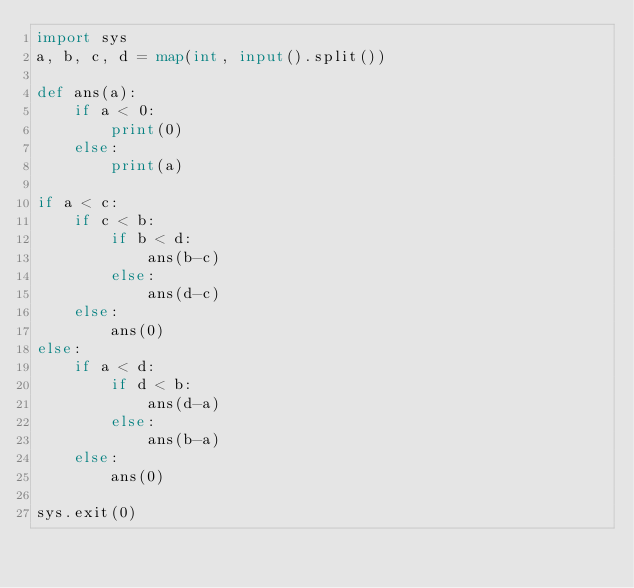Convert code to text. <code><loc_0><loc_0><loc_500><loc_500><_Python_>import sys
a, b, c, d = map(int, input().split())

def ans(a):
    if a < 0:
        print(0) 
    else:
        print(a)

if a < c:
    if c < b:
        if b < d:
            ans(b-c)
        else:
            ans(d-c)
    else:
        ans(0)
else:
    if a < d:
        if d < b:
            ans(d-a)
        else:
            ans(b-a)
    else:
        ans(0)

sys.exit(0)
</code> 